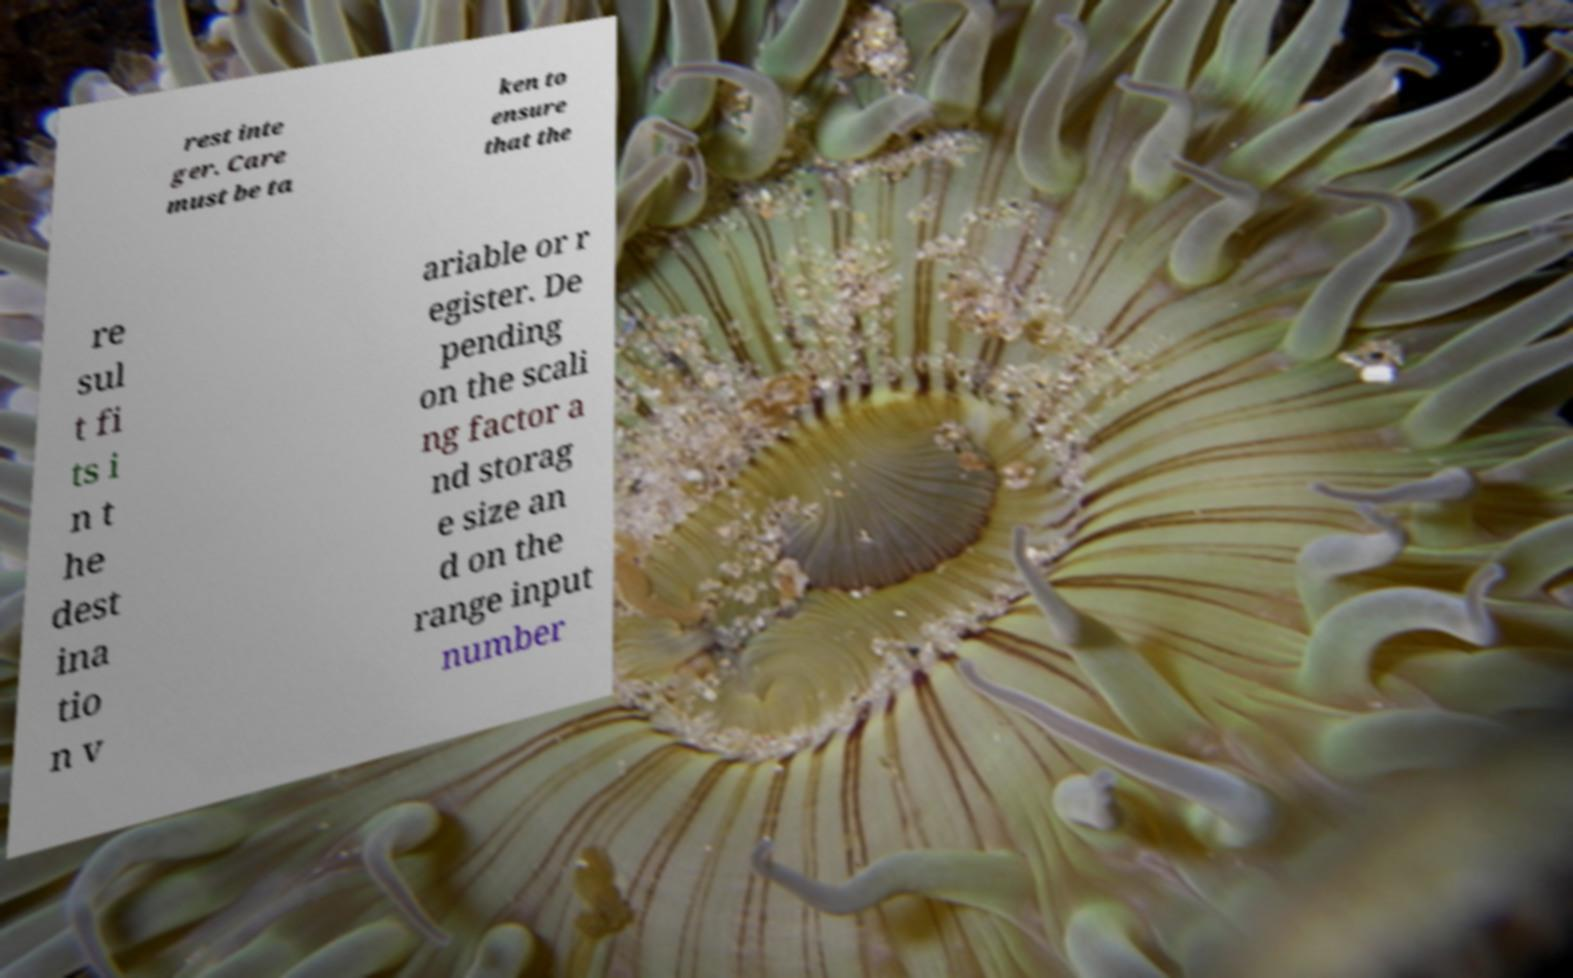Could you assist in decoding the text presented in this image and type it out clearly? rest inte ger. Care must be ta ken to ensure that the re sul t fi ts i n t he dest ina tio n v ariable or r egister. De pending on the scali ng factor a nd storag e size an d on the range input number 